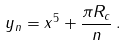Convert formula to latex. <formula><loc_0><loc_0><loc_500><loc_500>y _ { n } = x ^ { 5 } + \frac { \pi R _ { c } } { n } \, .</formula> 